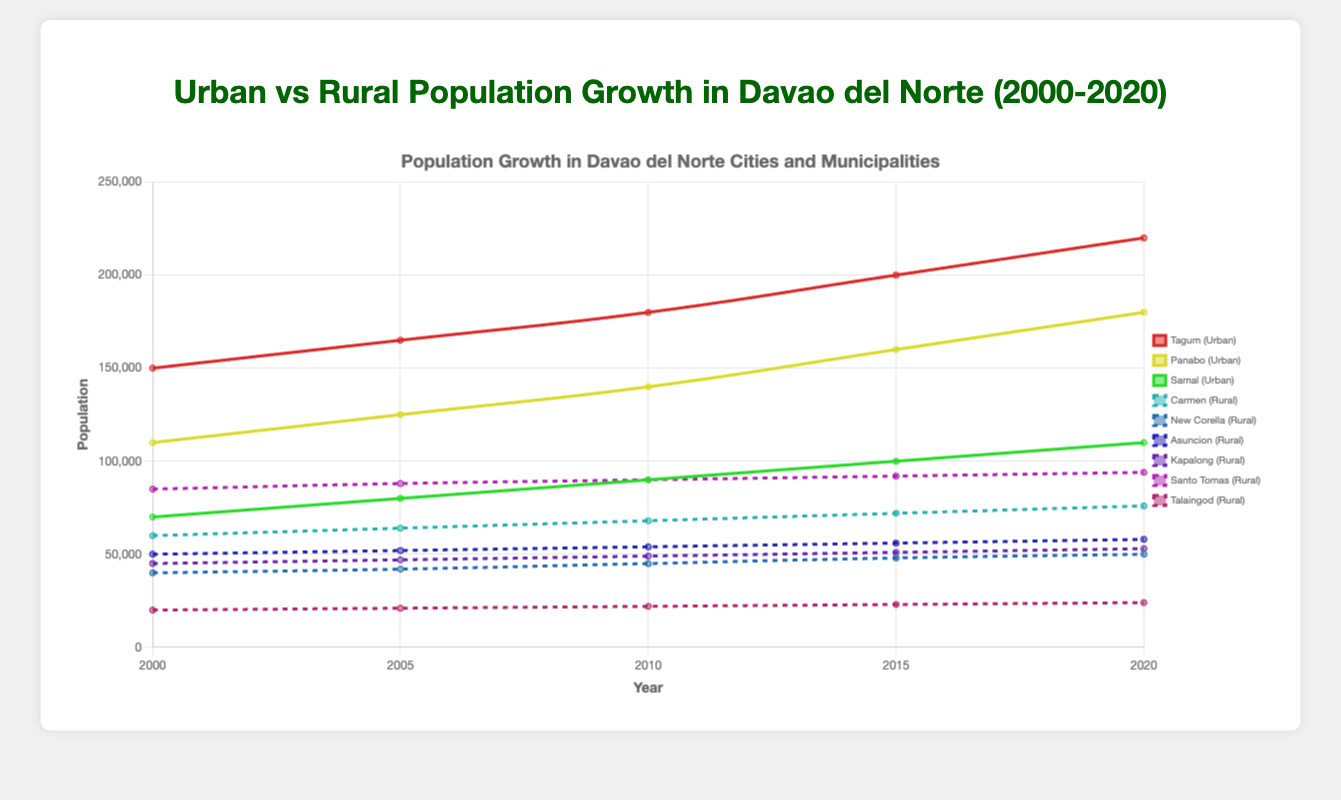What was the overall urban population in 2010? The urban population consists of Tagum, Panabo, and Samal. In 2010, the populations were Tagum (180,000), Panabo (140,000), and Samal (90,000). Adding these values: 180,000 + 140,000 + 90,000 = 410,000
Answer: 410,000 Which urban area had the highest population growth between 2000 and 2020? The populations in 2000 and 2020 for each urban area are: Tagum (150,000 to 220,000), Panabo (110,000 to 180,000), Samal (70,000 to 110,000). Growth: Tagum (220,000 - 150,000 = 70,000), Panabo (180,000 - 110,000 = 70,000), Samal (110,000 - 70,000 = 40,000). Both Tagum and Panabo had the highest growth of 70,000
Answer: Tagum and Panabo How did the rural population of Carmen change from 2000 to 2020? The rural population of Carmen in 2000 was 60,000 and in 2020 it was 76,000. The change is 76,000 - 60,000 = 16,000
Answer: 16,000 Which area had the smallest population in 2020? Comparing the 2020 populations: Tagum (220,000), Panabo (180,000), Samal (110,000), Carmen (76,000), New Corella (50,000), Asuncion (58,000), Kapalong (53,000), Santo Tomas (94,000), Talaingod (24,000). Talaingod has the smallest population of 24,000
Answer: Talaingod What is the trend of population growth in urban areas from 2000 to 2020? The populations in 2000 and 2020 for urban areas are: Tagum (150,000 to 220,000), Panabo (110,000 to 180,000), Samal (70,000 to 110,000). All urban areas show a rising trend over the years
Answer: Rising trend Compare the rural population of Santo Tomas in 2000 and 2020. The rural population of Santo Tomas in 2000 was 85,000 and in 2020 it was 94,000. The difference is 94,000 - 85,000 = 9,000
Answer: 94,000 is greater by 9,000 Which urban area showed the least growth in population from 2000 to 2020? The populations in 2000 and 2020 for urban areas are: Tagum (150,000 to 220,000), Panabo (110,000 to 180,000), Samal (70,000 to 110,000). Growth: Tagum (70,000), Panabo (70,000), Samal (40,000). Samal had the least growth of 40,000
Answer: Samal What is the average rural population of New Corella from 2000 to 2020? The rural populations of New Corella over the years are 40,000 (2000), 42,000 (2005), 45,000 (2010), 48,000 (2015), 50,000 (2020). Sum: 40,000 + 42,000 + 45,000 + 48,000 + 50,000 = 225,000. Average: 225,000 / 5 = 45,000
Answer: 45,000 Which has a higher population in 2020, rural Santo Tomas or urban Panabo? In 2020, Santo Tomas (rural) has 94,000, Panabo (urban) has 180,000. Comparing these: 180,000 > 94,000
Answer: Urban Panabo What's the total population (urban and rural) of Davao del Norte in 2020? The populations in 2020: Tagum (220,000), Panabo (180,000), Samal (110,000), Carmen (76,000), New Corella (50,000), Asuncion (58,000), Kapalong (53,000), Santo Tomas (94,000), Talaingod (24,000). Sum: 220,000 + 180,000 + 110,000 + 76,000 + 50,000 + 58,000 + 53,000 + 94,000 + 24,000 = 865,000
Answer: 865,000 